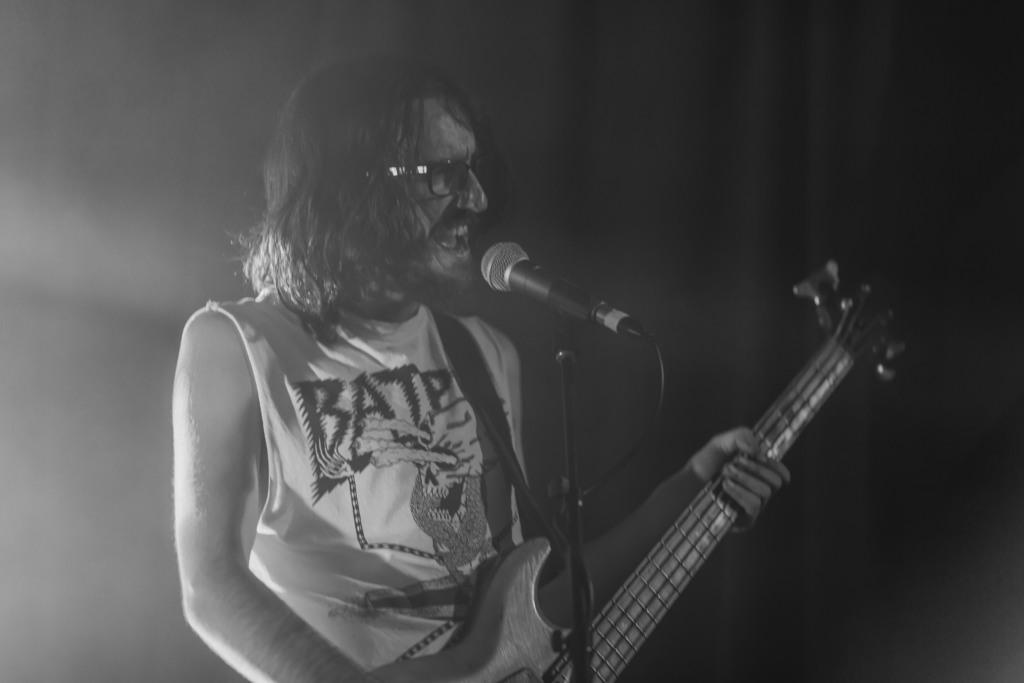Who is the main subject in the image? There is a man in the image. What is the man wearing? The man is wearing spectacles. What is the man holding? The man is holding a guitar. What is the man doing with the guitar? The man is playing the guitar. What is the man doing with his mouth? The man is singing into a microphone. What is the color of the background in the image? The background of the image is dark. What is the man's grandfather doing in the image? There is no mention of a grandfather in the image. --- Facts: 1. There is a car in the image. 2. The car is red. 3. The car has four wheels. 4. The car has a sunroof. 5. The car is parked on the street. Absurd Topics: rainbow Conversation: What is the main subject in the image? There is a car in the image. What color is the car? The car is red. How many wheels does the car have? The car has four wheels. What special feature does the car have? The car has a sunroof. Where is the car located in the image? The car is parked on the street. Reasoning: Let's think step by step in order to produce the conversation. We start by identifying the main subject of the image, which is the car. Next, we describe specific features of the car, such as its color, the number of wheels it has, and the presence of a sunroof. Then, we observe the location of the car in the image, noting that it is parked on the street. Absurd Question/Answer: Can you see a rainbow in the image? There is no mention of a rainbow in the image. 